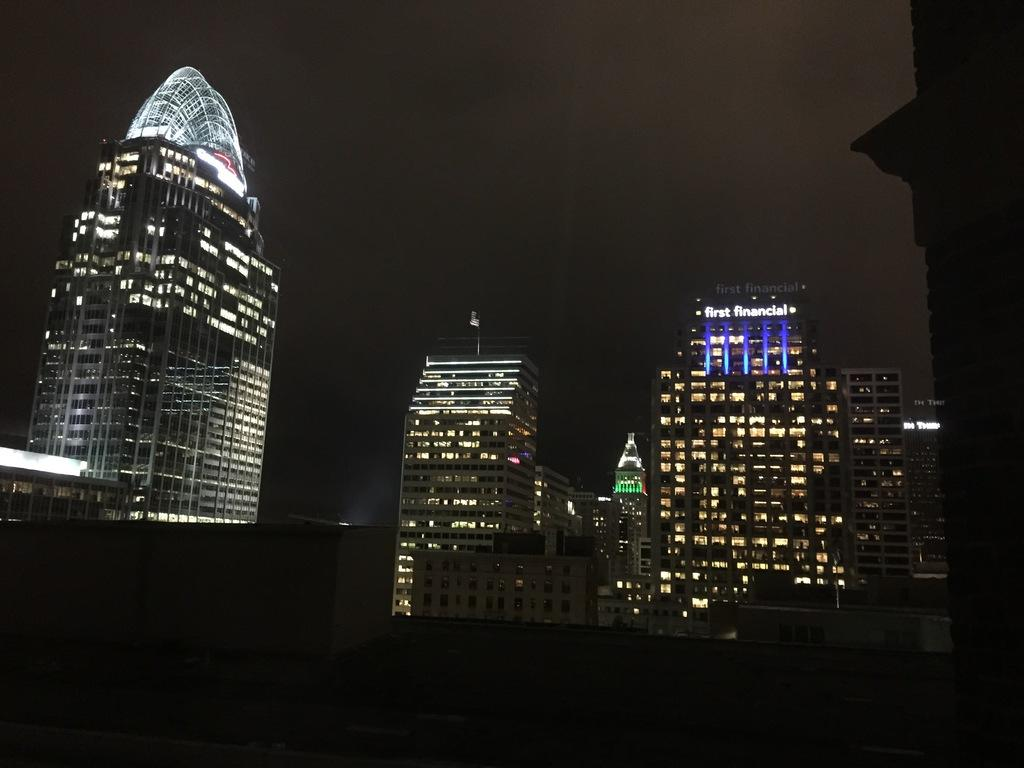What type of structures are present in the image? There are buildings in the image. What can be seen inside the buildings? There are lights visible inside the buildings. What is visible in the background of the image? The sky is visible in the background of the image. How would you describe the sky in the image? The sky is dark in the image. What type of chalk is being used to draw on the buildings in the image? There is no chalk or drawing present on the buildings in the image. Can you tell me who the guide is in the image? There is no guide or indication of a guided tour in the image. 